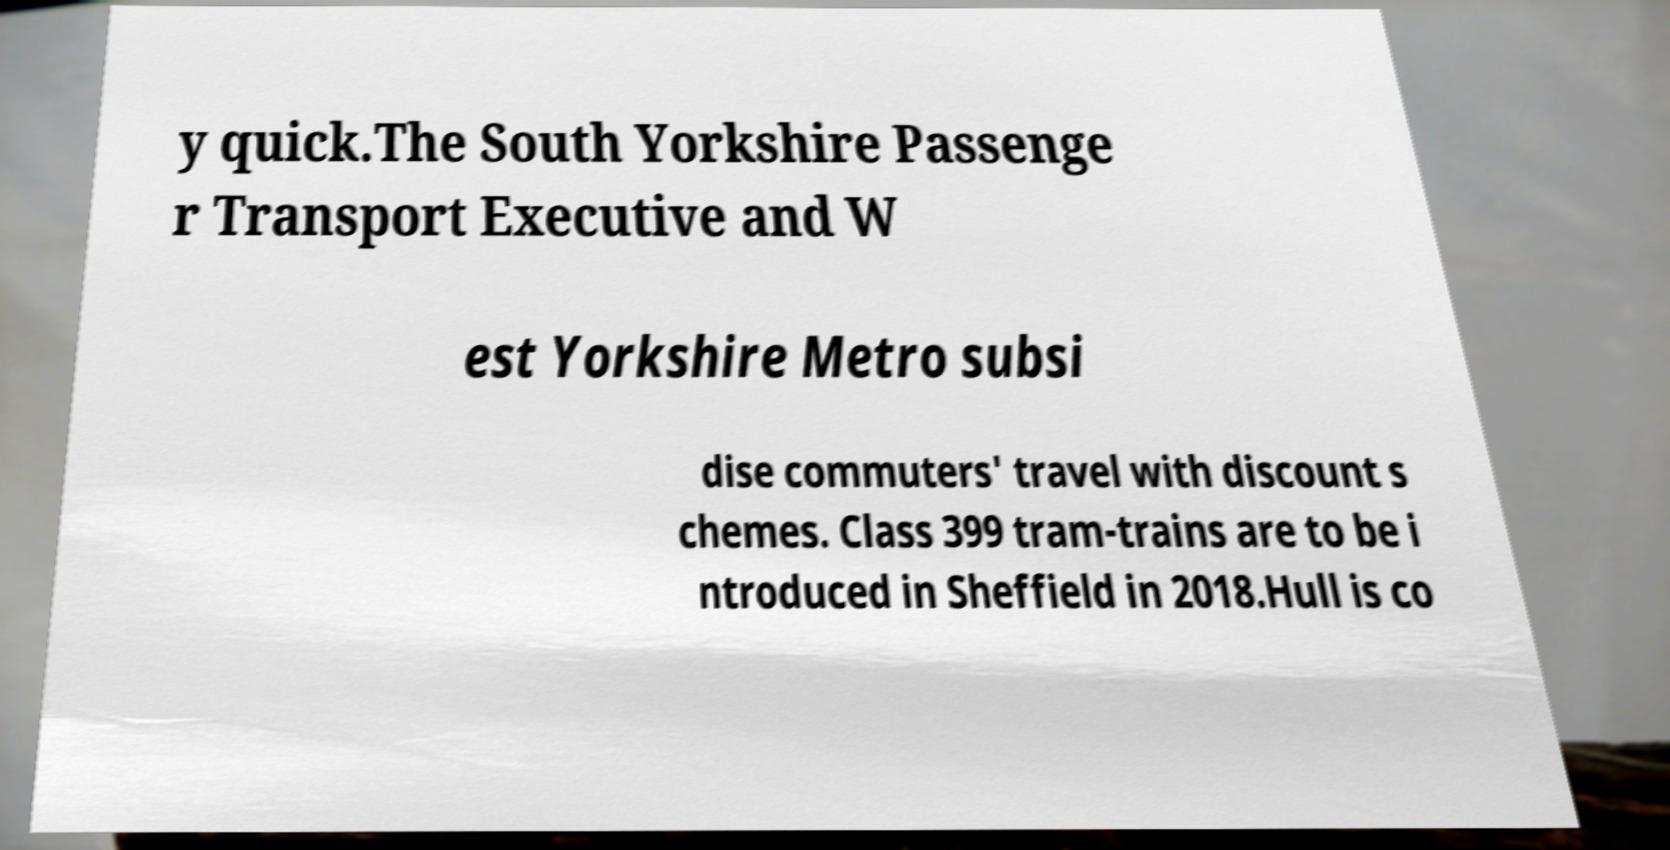What messages or text are displayed in this image? I need them in a readable, typed format. y quick.The South Yorkshire Passenge r Transport Executive and W est Yorkshire Metro subsi dise commuters' travel with discount s chemes. Class 399 tram-trains are to be i ntroduced in Sheffield in 2018.Hull is co 